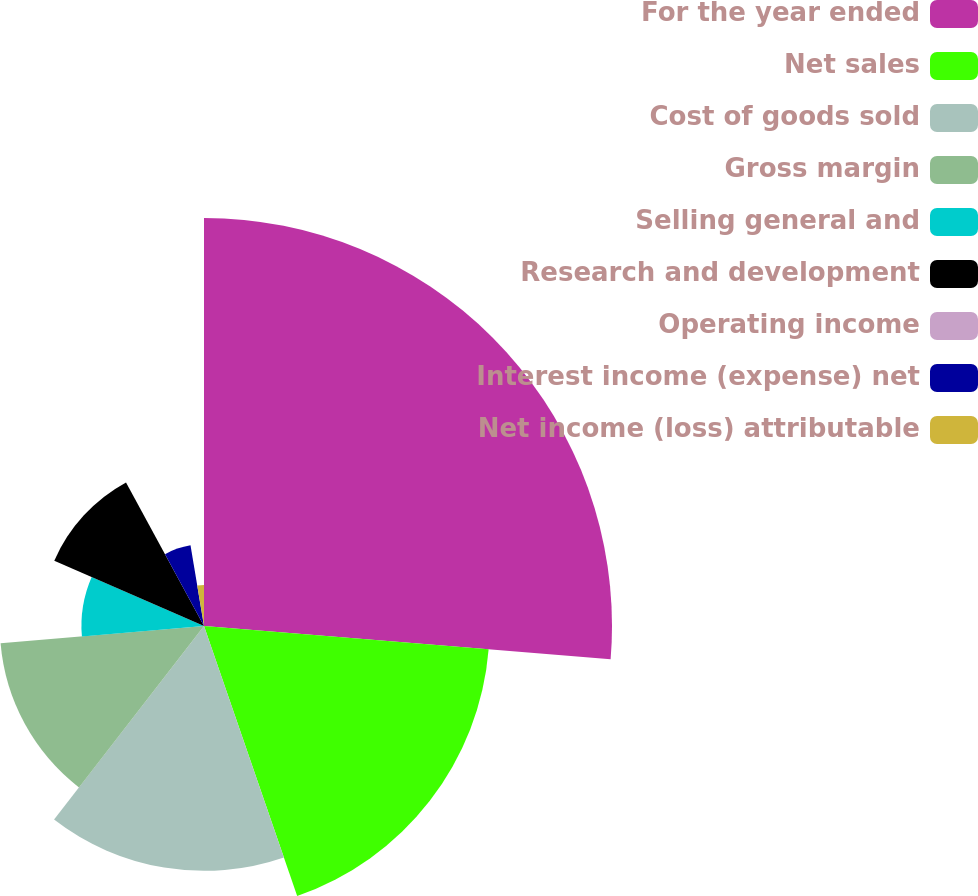<chart> <loc_0><loc_0><loc_500><loc_500><pie_chart><fcel>For the year ended<fcel>Net sales<fcel>Cost of goods sold<fcel>Gross margin<fcel>Selling general and<fcel>Research and development<fcel>Operating income<fcel>Interest income (expense) net<fcel>Net income (loss) attributable<nl><fcel>26.3%<fcel>18.41%<fcel>15.78%<fcel>13.16%<fcel>7.9%<fcel>10.53%<fcel>0.01%<fcel>5.27%<fcel>2.64%<nl></chart> 